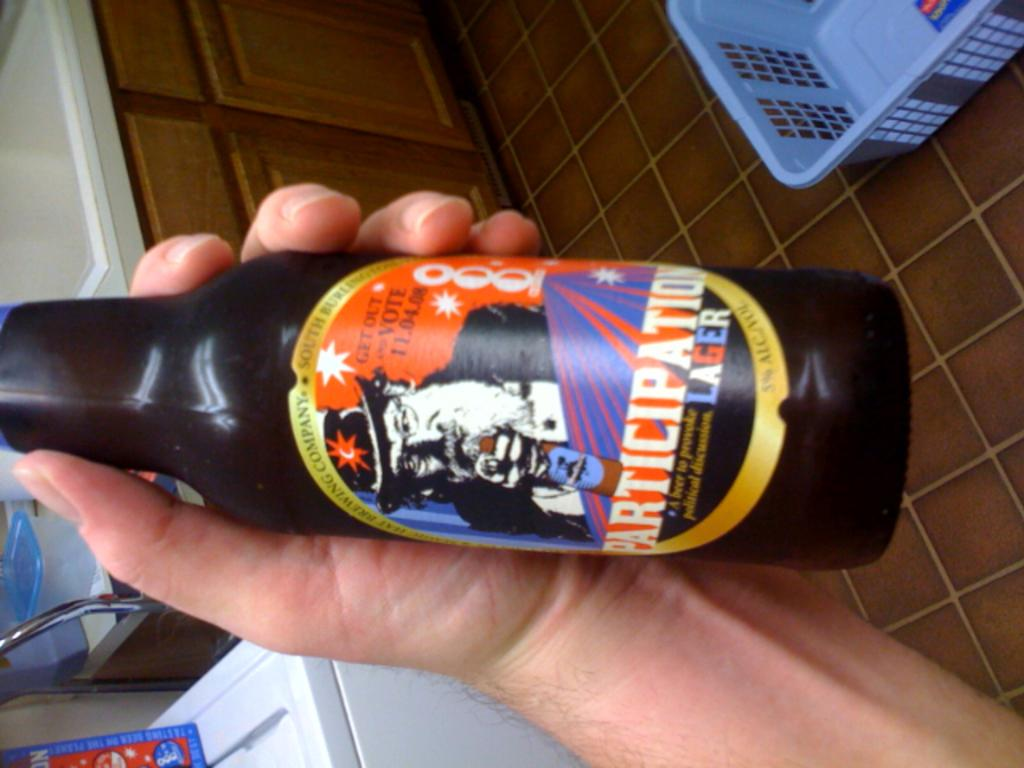<image>
Provide a brief description of the given image. the word participation that is on a bottle 